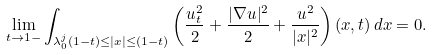<formula> <loc_0><loc_0><loc_500><loc_500>\lim _ { t \to 1 - } \int _ { \lambda _ { 0 } ^ { j } ( 1 - t ) \leq | x | \leq ( 1 - t ) } \left ( \frac { u _ { t } ^ { 2 } } { 2 } + \frac { | \nabla u | ^ { 2 } } { 2 } + \frac { u ^ { 2 } } { | x | ^ { 2 } } \right ) ( x , t ) \, d x = 0 .</formula> 